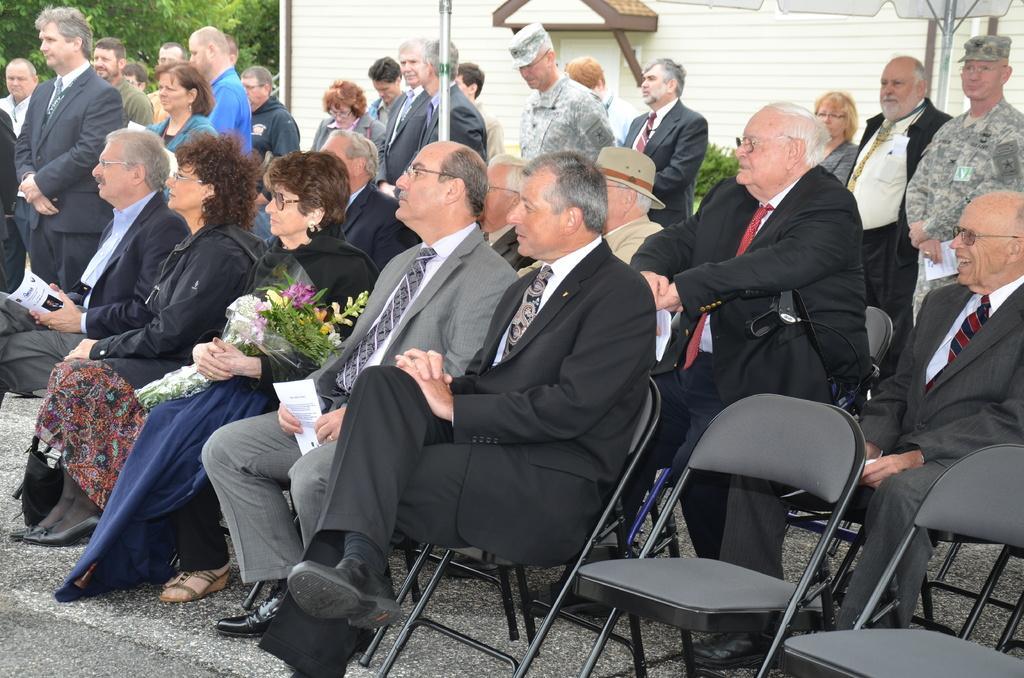Describe this image in one or two sentences. In this image, group of people are sat on the black chairs. Here a woman is holding a bouquet , few are holding papers. At the background, we can see so many peoples are standing ,plants, wall, rod. Trees on the left side. 